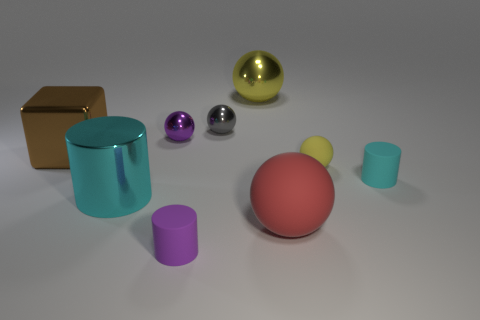Subtract all yellow balls. How many balls are left? 3 Subtract all yellow shiny balls. How many balls are left? 4 Subtract all brown balls. Subtract all cyan blocks. How many balls are left? 5 Subtract all spheres. How many objects are left? 4 Add 3 large objects. How many large objects are left? 7 Add 4 tiny metal cylinders. How many tiny metal cylinders exist? 4 Subtract 0 blue cubes. How many objects are left? 9 Subtract all red spheres. Subtract all purple metal things. How many objects are left? 7 